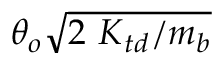<formula> <loc_0><loc_0><loc_500><loc_500>\theta _ { o } \sqrt { 2 { \ K } _ { t d } / m _ { b } }</formula> 